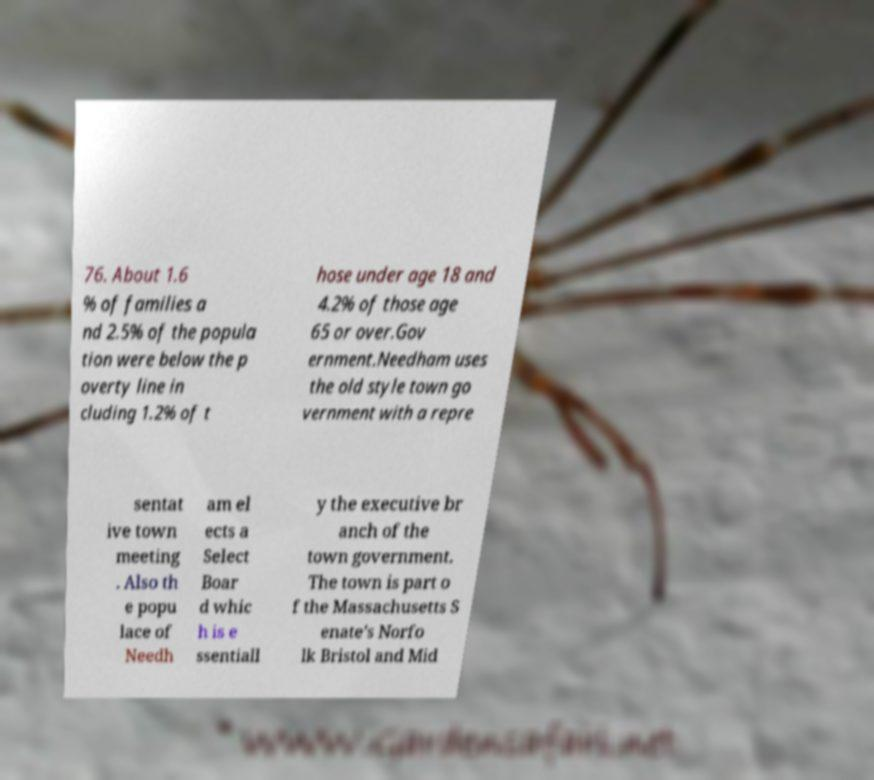Can you accurately transcribe the text from the provided image for me? 76. About 1.6 % of families a nd 2.5% of the popula tion were below the p overty line in cluding 1.2% of t hose under age 18 and 4.2% of those age 65 or over.Gov ernment.Needham uses the old style town go vernment with a repre sentat ive town meeting . Also th e popu lace of Needh am el ects a Select Boar d whic h is e ssentiall y the executive br anch of the town government. The town is part o f the Massachusetts S enate's Norfo lk Bristol and Mid 